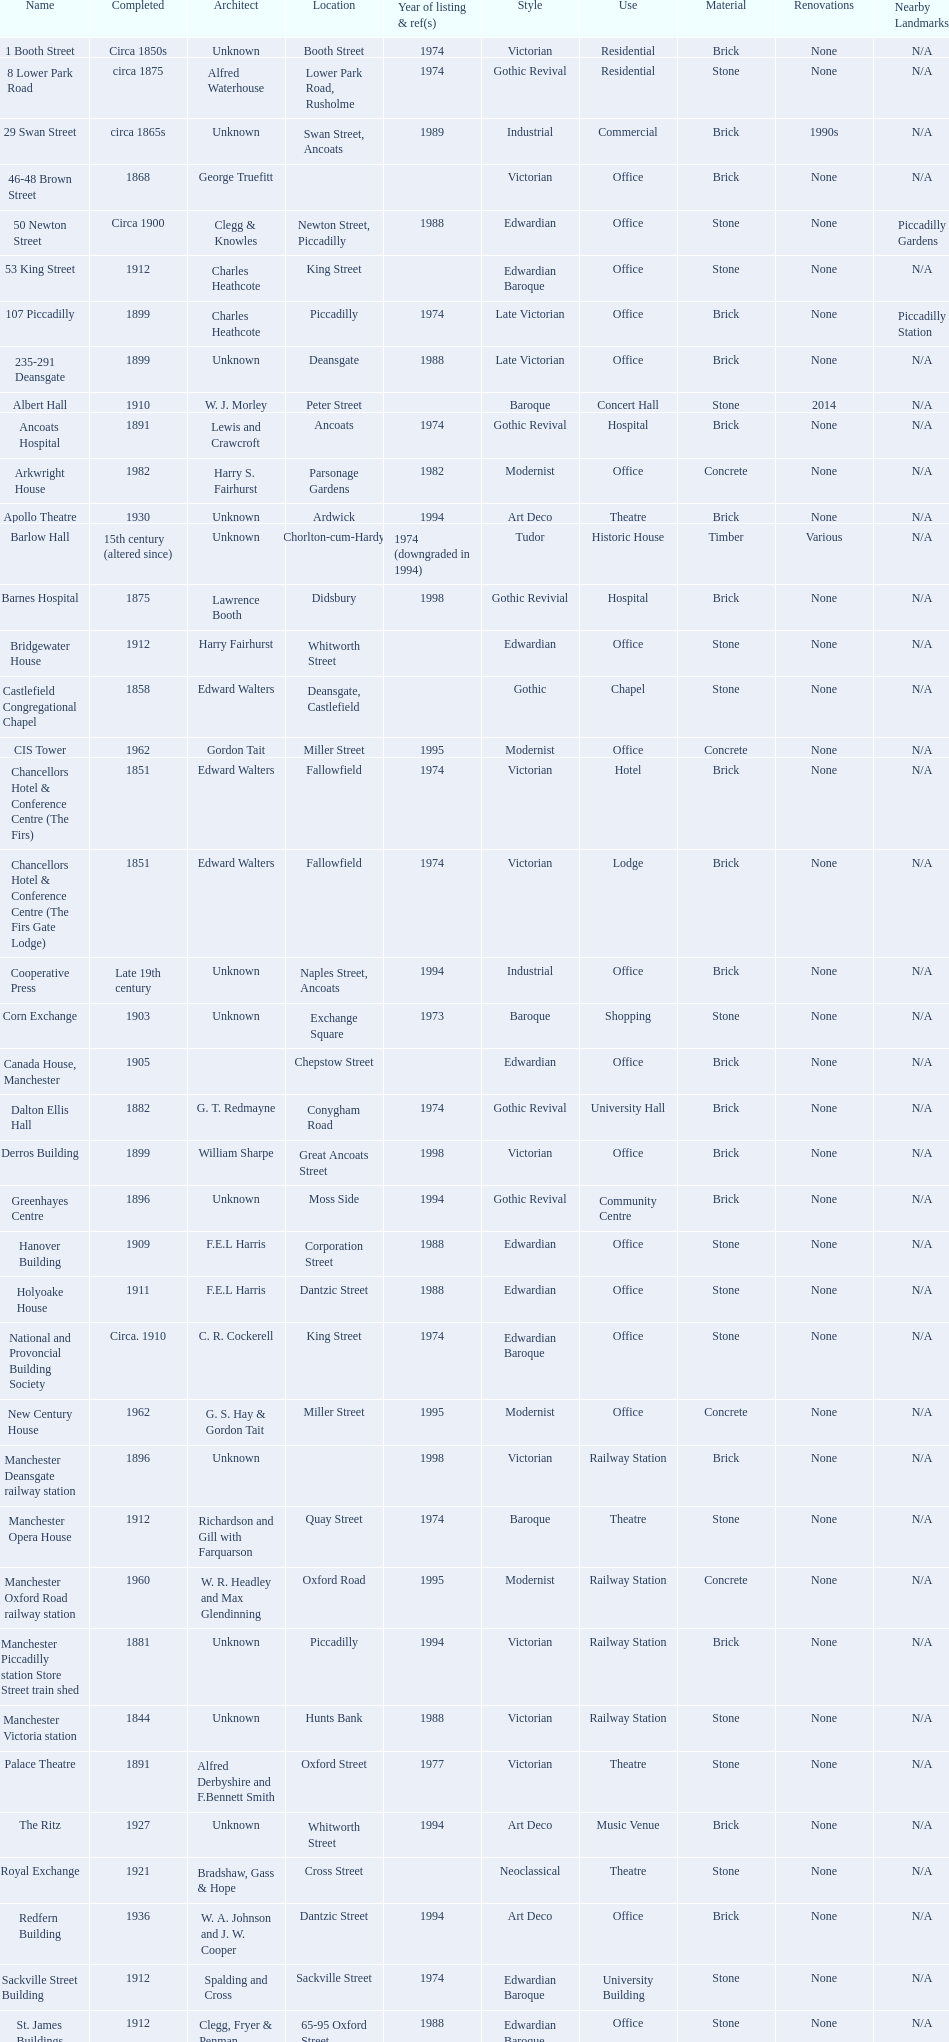Was charles heathcote the architect of ancoats hospital and apollo theatre? No. 